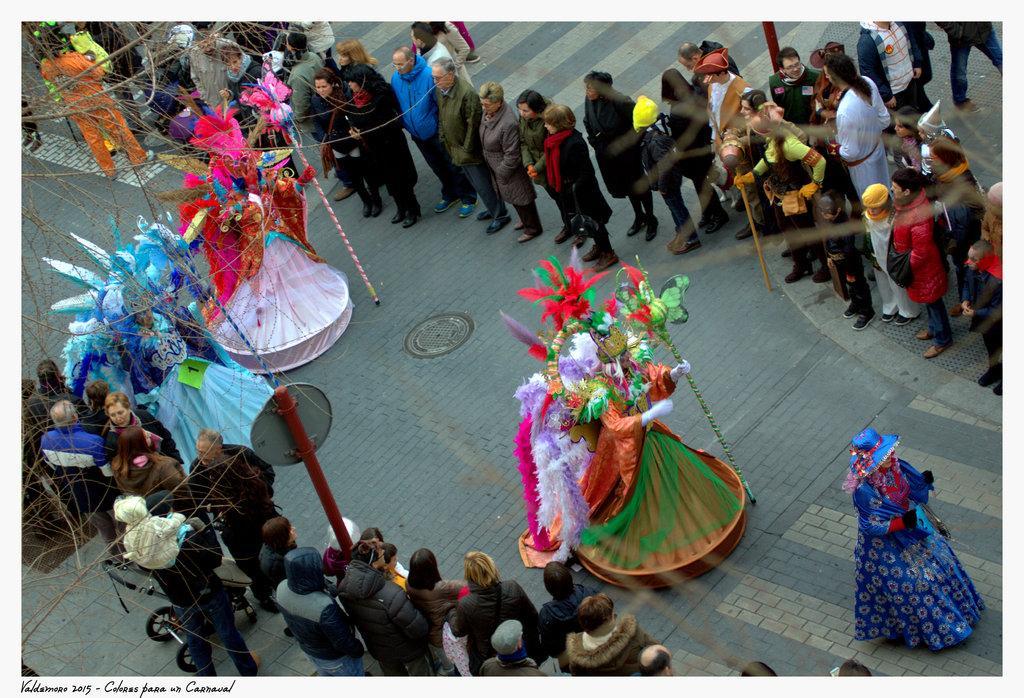Please provide a concise description of this image. This is an outside view. Here I can see a few people wearing costumes and walking on the road. On both sides of the road many people are standing and looking at the people who are wearing costumes. 